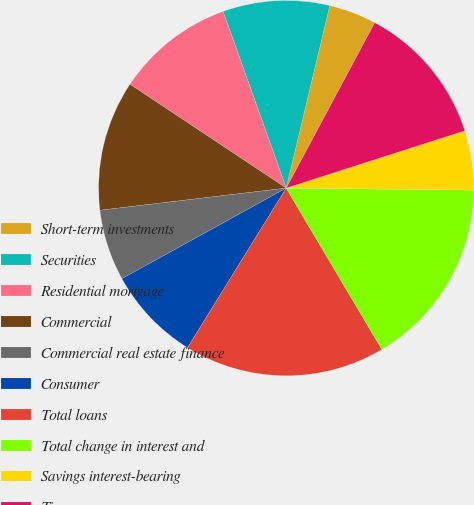Convert chart to OTSL. <chart><loc_0><loc_0><loc_500><loc_500><pie_chart><fcel>Short-term investments<fcel>Securities<fcel>Residential mortgage<fcel>Commercial<fcel>Commercial real estate finance<fcel>Consumer<fcel>Total loans<fcel>Total change in interest and<fcel>Savings interest-bearing<fcel>Time<nl><fcel>4.09%<fcel>9.19%<fcel>10.2%<fcel>11.22%<fcel>6.13%<fcel>8.17%<fcel>17.33%<fcel>16.31%<fcel>5.11%<fcel>12.24%<nl></chart> 